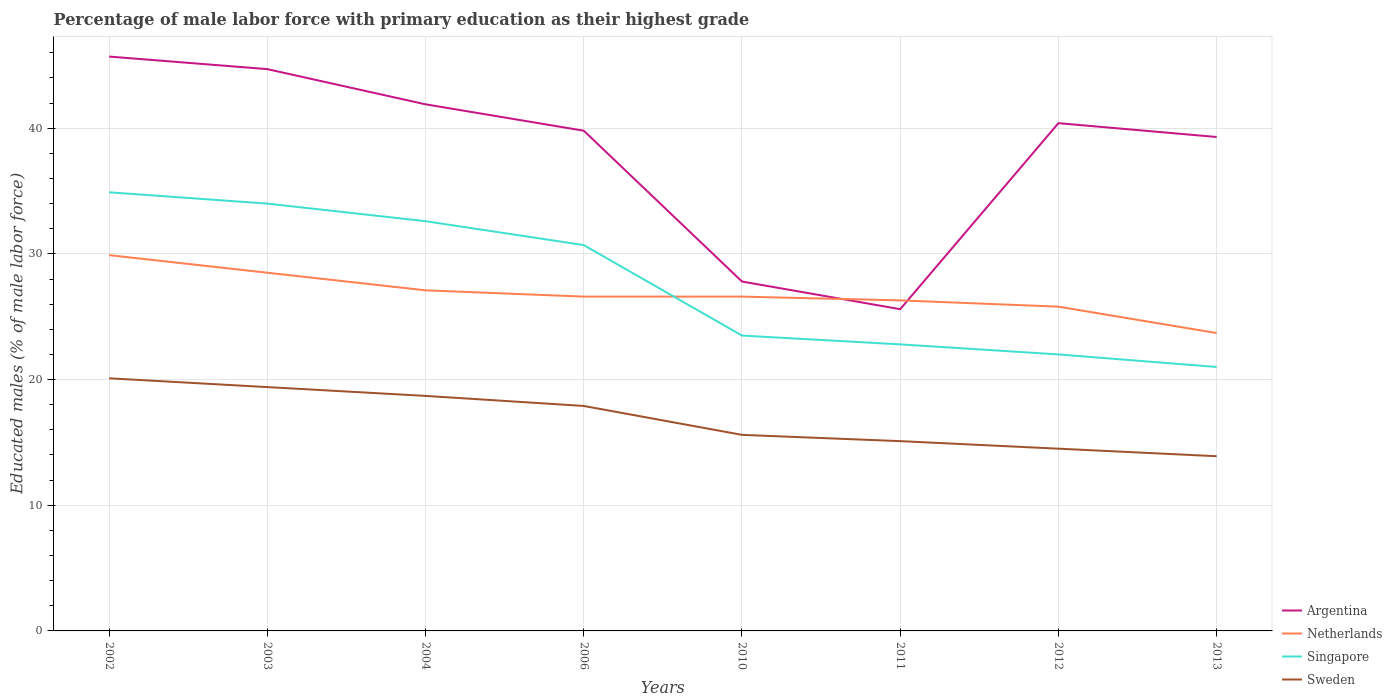How many different coloured lines are there?
Your answer should be compact. 4. Across all years, what is the maximum percentage of male labor force with primary education in Singapore?
Provide a short and direct response. 21. What is the total percentage of male labor force with primary education in Netherlands in the graph?
Make the answer very short. 2.6. What is the difference between the highest and the second highest percentage of male labor force with primary education in Argentina?
Offer a very short reply. 20.1. How many years are there in the graph?
Make the answer very short. 8. What is the difference between two consecutive major ticks on the Y-axis?
Make the answer very short. 10. Are the values on the major ticks of Y-axis written in scientific E-notation?
Offer a very short reply. No. Does the graph contain grids?
Your answer should be very brief. Yes. Where does the legend appear in the graph?
Your answer should be very brief. Bottom right. What is the title of the graph?
Offer a terse response. Percentage of male labor force with primary education as their highest grade. Does "Cayman Islands" appear as one of the legend labels in the graph?
Ensure brevity in your answer.  No. What is the label or title of the Y-axis?
Give a very brief answer. Educated males (% of male labor force). What is the Educated males (% of male labor force) of Argentina in 2002?
Offer a terse response. 45.7. What is the Educated males (% of male labor force) in Netherlands in 2002?
Your answer should be compact. 29.9. What is the Educated males (% of male labor force) in Singapore in 2002?
Ensure brevity in your answer.  34.9. What is the Educated males (% of male labor force) of Sweden in 2002?
Ensure brevity in your answer.  20.1. What is the Educated males (% of male labor force) in Argentina in 2003?
Your answer should be compact. 44.7. What is the Educated males (% of male labor force) in Singapore in 2003?
Offer a very short reply. 34. What is the Educated males (% of male labor force) of Sweden in 2003?
Your response must be concise. 19.4. What is the Educated males (% of male labor force) in Argentina in 2004?
Your response must be concise. 41.9. What is the Educated males (% of male labor force) of Netherlands in 2004?
Ensure brevity in your answer.  27.1. What is the Educated males (% of male labor force) in Singapore in 2004?
Keep it short and to the point. 32.6. What is the Educated males (% of male labor force) of Sweden in 2004?
Give a very brief answer. 18.7. What is the Educated males (% of male labor force) of Argentina in 2006?
Your answer should be compact. 39.8. What is the Educated males (% of male labor force) in Netherlands in 2006?
Make the answer very short. 26.6. What is the Educated males (% of male labor force) of Singapore in 2006?
Ensure brevity in your answer.  30.7. What is the Educated males (% of male labor force) of Sweden in 2006?
Your answer should be compact. 17.9. What is the Educated males (% of male labor force) in Argentina in 2010?
Offer a terse response. 27.8. What is the Educated males (% of male labor force) of Netherlands in 2010?
Offer a terse response. 26.6. What is the Educated males (% of male labor force) in Sweden in 2010?
Your answer should be compact. 15.6. What is the Educated males (% of male labor force) in Argentina in 2011?
Offer a terse response. 25.6. What is the Educated males (% of male labor force) of Netherlands in 2011?
Ensure brevity in your answer.  26.3. What is the Educated males (% of male labor force) in Singapore in 2011?
Keep it short and to the point. 22.8. What is the Educated males (% of male labor force) of Sweden in 2011?
Make the answer very short. 15.1. What is the Educated males (% of male labor force) of Argentina in 2012?
Provide a short and direct response. 40.4. What is the Educated males (% of male labor force) in Netherlands in 2012?
Your answer should be compact. 25.8. What is the Educated males (% of male labor force) of Singapore in 2012?
Offer a very short reply. 22. What is the Educated males (% of male labor force) of Argentina in 2013?
Provide a short and direct response. 39.3. What is the Educated males (% of male labor force) in Netherlands in 2013?
Provide a succinct answer. 23.7. What is the Educated males (% of male labor force) in Sweden in 2013?
Provide a succinct answer. 13.9. Across all years, what is the maximum Educated males (% of male labor force) of Argentina?
Make the answer very short. 45.7. Across all years, what is the maximum Educated males (% of male labor force) in Netherlands?
Provide a short and direct response. 29.9. Across all years, what is the maximum Educated males (% of male labor force) in Singapore?
Ensure brevity in your answer.  34.9. Across all years, what is the maximum Educated males (% of male labor force) in Sweden?
Your answer should be compact. 20.1. Across all years, what is the minimum Educated males (% of male labor force) of Argentina?
Your answer should be very brief. 25.6. Across all years, what is the minimum Educated males (% of male labor force) in Netherlands?
Offer a terse response. 23.7. Across all years, what is the minimum Educated males (% of male labor force) of Sweden?
Offer a very short reply. 13.9. What is the total Educated males (% of male labor force) of Argentina in the graph?
Ensure brevity in your answer.  305.2. What is the total Educated males (% of male labor force) of Netherlands in the graph?
Offer a terse response. 214.5. What is the total Educated males (% of male labor force) of Singapore in the graph?
Your response must be concise. 221.5. What is the total Educated males (% of male labor force) in Sweden in the graph?
Ensure brevity in your answer.  135.2. What is the difference between the Educated males (% of male labor force) of Argentina in 2002 and that in 2003?
Your answer should be very brief. 1. What is the difference between the Educated males (% of male labor force) of Singapore in 2002 and that in 2003?
Your answer should be very brief. 0.9. What is the difference between the Educated males (% of male labor force) of Sweden in 2002 and that in 2003?
Your answer should be very brief. 0.7. What is the difference between the Educated males (% of male labor force) of Argentina in 2002 and that in 2004?
Your answer should be very brief. 3.8. What is the difference between the Educated males (% of male labor force) of Singapore in 2002 and that in 2004?
Provide a short and direct response. 2.3. What is the difference between the Educated males (% of male labor force) of Sweden in 2002 and that in 2004?
Make the answer very short. 1.4. What is the difference between the Educated males (% of male labor force) in Sweden in 2002 and that in 2010?
Offer a terse response. 4.5. What is the difference between the Educated males (% of male labor force) of Argentina in 2002 and that in 2011?
Provide a succinct answer. 20.1. What is the difference between the Educated males (% of male labor force) of Netherlands in 2002 and that in 2011?
Your response must be concise. 3.6. What is the difference between the Educated males (% of male labor force) in Netherlands in 2002 and that in 2012?
Make the answer very short. 4.1. What is the difference between the Educated males (% of male labor force) in Singapore in 2002 and that in 2012?
Provide a succinct answer. 12.9. What is the difference between the Educated males (% of male labor force) of Sweden in 2002 and that in 2012?
Give a very brief answer. 5.6. What is the difference between the Educated males (% of male labor force) of Argentina in 2002 and that in 2013?
Your answer should be very brief. 6.4. What is the difference between the Educated males (% of male labor force) in Netherlands in 2002 and that in 2013?
Your answer should be compact. 6.2. What is the difference between the Educated males (% of male labor force) in Singapore in 2002 and that in 2013?
Provide a short and direct response. 13.9. What is the difference between the Educated males (% of male labor force) in Argentina in 2003 and that in 2004?
Provide a short and direct response. 2.8. What is the difference between the Educated males (% of male labor force) in Argentina in 2003 and that in 2006?
Your answer should be compact. 4.9. What is the difference between the Educated males (% of male labor force) of Netherlands in 2003 and that in 2006?
Keep it short and to the point. 1.9. What is the difference between the Educated males (% of male labor force) in Singapore in 2003 and that in 2006?
Your response must be concise. 3.3. What is the difference between the Educated males (% of male labor force) in Argentina in 2003 and that in 2010?
Your answer should be very brief. 16.9. What is the difference between the Educated males (% of male labor force) of Netherlands in 2003 and that in 2010?
Make the answer very short. 1.9. What is the difference between the Educated males (% of male labor force) in Singapore in 2003 and that in 2010?
Your response must be concise. 10.5. What is the difference between the Educated males (% of male labor force) in Netherlands in 2003 and that in 2011?
Offer a very short reply. 2.2. What is the difference between the Educated males (% of male labor force) of Singapore in 2003 and that in 2011?
Provide a short and direct response. 11.2. What is the difference between the Educated males (% of male labor force) in Argentina in 2003 and that in 2012?
Your answer should be compact. 4.3. What is the difference between the Educated males (% of male labor force) in Singapore in 2003 and that in 2012?
Offer a terse response. 12. What is the difference between the Educated males (% of male labor force) of Sweden in 2003 and that in 2012?
Your response must be concise. 4.9. What is the difference between the Educated males (% of male labor force) in Singapore in 2003 and that in 2013?
Your answer should be compact. 13. What is the difference between the Educated males (% of male labor force) in Argentina in 2004 and that in 2006?
Your answer should be compact. 2.1. What is the difference between the Educated males (% of male labor force) in Netherlands in 2004 and that in 2006?
Ensure brevity in your answer.  0.5. What is the difference between the Educated males (% of male labor force) of Sweden in 2004 and that in 2006?
Offer a very short reply. 0.8. What is the difference between the Educated males (% of male labor force) of Netherlands in 2004 and that in 2010?
Keep it short and to the point. 0.5. What is the difference between the Educated males (% of male labor force) of Singapore in 2004 and that in 2010?
Provide a succinct answer. 9.1. What is the difference between the Educated males (% of male labor force) of Sweden in 2004 and that in 2010?
Keep it short and to the point. 3.1. What is the difference between the Educated males (% of male labor force) in Argentina in 2004 and that in 2011?
Your response must be concise. 16.3. What is the difference between the Educated males (% of male labor force) in Netherlands in 2004 and that in 2011?
Offer a terse response. 0.8. What is the difference between the Educated males (% of male labor force) in Sweden in 2004 and that in 2011?
Make the answer very short. 3.6. What is the difference between the Educated males (% of male labor force) in Sweden in 2004 and that in 2013?
Your response must be concise. 4.8. What is the difference between the Educated males (% of male labor force) of Argentina in 2006 and that in 2010?
Give a very brief answer. 12. What is the difference between the Educated males (% of male labor force) in Netherlands in 2006 and that in 2010?
Your answer should be compact. 0. What is the difference between the Educated males (% of male labor force) of Singapore in 2006 and that in 2010?
Your response must be concise. 7.2. What is the difference between the Educated males (% of male labor force) of Sweden in 2006 and that in 2010?
Your answer should be compact. 2.3. What is the difference between the Educated males (% of male labor force) in Netherlands in 2006 and that in 2011?
Offer a terse response. 0.3. What is the difference between the Educated males (% of male labor force) in Argentina in 2006 and that in 2012?
Your answer should be compact. -0.6. What is the difference between the Educated males (% of male labor force) in Sweden in 2006 and that in 2012?
Offer a terse response. 3.4. What is the difference between the Educated males (% of male labor force) in Netherlands in 2006 and that in 2013?
Give a very brief answer. 2.9. What is the difference between the Educated males (% of male labor force) of Sweden in 2006 and that in 2013?
Offer a very short reply. 4. What is the difference between the Educated males (% of male labor force) in Singapore in 2010 and that in 2011?
Ensure brevity in your answer.  0.7. What is the difference between the Educated males (% of male labor force) of Argentina in 2010 and that in 2012?
Make the answer very short. -12.6. What is the difference between the Educated males (% of male labor force) of Netherlands in 2010 and that in 2012?
Make the answer very short. 0.8. What is the difference between the Educated males (% of male labor force) in Argentina in 2010 and that in 2013?
Provide a short and direct response. -11.5. What is the difference between the Educated males (% of male labor force) in Singapore in 2010 and that in 2013?
Make the answer very short. 2.5. What is the difference between the Educated males (% of male labor force) of Sweden in 2010 and that in 2013?
Provide a succinct answer. 1.7. What is the difference between the Educated males (% of male labor force) of Argentina in 2011 and that in 2012?
Give a very brief answer. -14.8. What is the difference between the Educated males (% of male labor force) in Netherlands in 2011 and that in 2012?
Make the answer very short. 0.5. What is the difference between the Educated males (% of male labor force) of Sweden in 2011 and that in 2012?
Offer a terse response. 0.6. What is the difference between the Educated males (% of male labor force) of Argentina in 2011 and that in 2013?
Your answer should be compact. -13.7. What is the difference between the Educated males (% of male labor force) in Singapore in 2011 and that in 2013?
Your answer should be compact. 1.8. What is the difference between the Educated males (% of male labor force) in Argentina in 2012 and that in 2013?
Ensure brevity in your answer.  1.1. What is the difference between the Educated males (% of male labor force) of Netherlands in 2012 and that in 2013?
Offer a very short reply. 2.1. What is the difference between the Educated males (% of male labor force) in Singapore in 2012 and that in 2013?
Give a very brief answer. 1. What is the difference between the Educated males (% of male labor force) of Argentina in 2002 and the Educated males (% of male labor force) of Netherlands in 2003?
Give a very brief answer. 17.2. What is the difference between the Educated males (% of male labor force) of Argentina in 2002 and the Educated males (% of male labor force) of Singapore in 2003?
Make the answer very short. 11.7. What is the difference between the Educated males (% of male labor force) of Argentina in 2002 and the Educated males (% of male labor force) of Sweden in 2003?
Make the answer very short. 26.3. What is the difference between the Educated males (% of male labor force) in Netherlands in 2002 and the Educated males (% of male labor force) in Singapore in 2003?
Make the answer very short. -4.1. What is the difference between the Educated males (% of male labor force) of Singapore in 2002 and the Educated males (% of male labor force) of Sweden in 2003?
Your response must be concise. 15.5. What is the difference between the Educated males (% of male labor force) in Argentina in 2002 and the Educated males (% of male labor force) in Sweden in 2004?
Your answer should be compact. 27. What is the difference between the Educated males (% of male labor force) in Argentina in 2002 and the Educated males (% of male labor force) in Netherlands in 2006?
Make the answer very short. 19.1. What is the difference between the Educated males (% of male labor force) in Argentina in 2002 and the Educated males (% of male labor force) in Singapore in 2006?
Make the answer very short. 15. What is the difference between the Educated males (% of male labor force) in Argentina in 2002 and the Educated males (% of male labor force) in Sweden in 2006?
Your response must be concise. 27.8. What is the difference between the Educated males (% of male labor force) of Singapore in 2002 and the Educated males (% of male labor force) of Sweden in 2006?
Provide a short and direct response. 17. What is the difference between the Educated males (% of male labor force) of Argentina in 2002 and the Educated males (% of male labor force) of Singapore in 2010?
Ensure brevity in your answer.  22.2. What is the difference between the Educated males (% of male labor force) of Argentina in 2002 and the Educated males (% of male labor force) of Sweden in 2010?
Offer a very short reply. 30.1. What is the difference between the Educated males (% of male labor force) in Netherlands in 2002 and the Educated males (% of male labor force) in Singapore in 2010?
Ensure brevity in your answer.  6.4. What is the difference between the Educated males (% of male labor force) of Netherlands in 2002 and the Educated males (% of male labor force) of Sweden in 2010?
Your answer should be very brief. 14.3. What is the difference between the Educated males (% of male labor force) in Singapore in 2002 and the Educated males (% of male labor force) in Sweden in 2010?
Your response must be concise. 19.3. What is the difference between the Educated males (% of male labor force) in Argentina in 2002 and the Educated males (% of male labor force) in Singapore in 2011?
Your answer should be very brief. 22.9. What is the difference between the Educated males (% of male labor force) in Argentina in 2002 and the Educated males (% of male labor force) in Sweden in 2011?
Keep it short and to the point. 30.6. What is the difference between the Educated males (% of male labor force) in Netherlands in 2002 and the Educated males (% of male labor force) in Sweden in 2011?
Your answer should be very brief. 14.8. What is the difference between the Educated males (% of male labor force) in Singapore in 2002 and the Educated males (% of male labor force) in Sweden in 2011?
Make the answer very short. 19.8. What is the difference between the Educated males (% of male labor force) of Argentina in 2002 and the Educated males (% of male labor force) of Netherlands in 2012?
Provide a short and direct response. 19.9. What is the difference between the Educated males (% of male labor force) in Argentina in 2002 and the Educated males (% of male labor force) in Singapore in 2012?
Your answer should be compact. 23.7. What is the difference between the Educated males (% of male labor force) of Argentina in 2002 and the Educated males (% of male labor force) of Sweden in 2012?
Offer a very short reply. 31.2. What is the difference between the Educated males (% of male labor force) in Netherlands in 2002 and the Educated males (% of male labor force) in Sweden in 2012?
Give a very brief answer. 15.4. What is the difference between the Educated males (% of male labor force) in Singapore in 2002 and the Educated males (% of male labor force) in Sweden in 2012?
Your answer should be very brief. 20.4. What is the difference between the Educated males (% of male labor force) in Argentina in 2002 and the Educated males (% of male labor force) in Singapore in 2013?
Keep it short and to the point. 24.7. What is the difference between the Educated males (% of male labor force) of Argentina in 2002 and the Educated males (% of male labor force) of Sweden in 2013?
Keep it short and to the point. 31.8. What is the difference between the Educated males (% of male labor force) of Netherlands in 2002 and the Educated males (% of male labor force) of Singapore in 2013?
Ensure brevity in your answer.  8.9. What is the difference between the Educated males (% of male labor force) in Netherlands in 2002 and the Educated males (% of male labor force) in Sweden in 2013?
Make the answer very short. 16. What is the difference between the Educated males (% of male labor force) of Singapore in 2002 and the Educated males (% of male labor force) of Sweden in 2013?
Offer a terse response. 21. What is the difference between the Educated males (% of male labor force) of Argentina in 2003 and the Educated males (% of male labor force) of Singapore in 2004?
Keep it short and to the point. 12.1. What is the difference between the Educated males (% of male labor force) in Netherlands in 2003 and the Educated males (% of male labor force) in Singapore in 2004?
Make the answer very short. -4.1. What is the difference between the Educated males (% of male labor force) of Netherlands in 2003 and the Educated males (% of male labor force) of Sweden in 2004?
Keep it short and to the point. 9.8. What is the difference between the Educated males (% of male labor force) in Singapore in 2003 and the Educated males (% of male labor force) in Sweden in 2004?
Your answer should be very brief. 15.3. What is the difference between the Educated males (% of male labor force) of Argentina in 2003 and the Educated males (% of male labor force) of Netherlands in 2006?
Make the answer very short. 18.1. What is the difference between the Educated males (% of male labor force) of Argentina in 2003 and the Educated males (% of male labor force) of Singapore in 2006?
Offer a very short reply. 14. What is the difference between the Educated males (% of male labor force) in Argentina in 2003 and the Educated males (% of male labor force) in Sweden in 2006?
Your response must be concise. 26.8. What is the difference between the Educated males (% of male labor force) of Netherlands in 2003 and the Educated males (% of male labor force) of Singapore in 2006?
Your answer should be compact. -2.2. What is the difference between the Educated males (% of male labor force) of Netherlands in 2003 and the Educated males (% of male labor force) of Sweden in 2006?
Keep it short and to the point. 10.6. What is the difference between the Educated males (% of male labor force) of Argentina in 2003 and the Educated males (% of male labor force) of Netherlands in 2010?
Provide a short and direct response. 18.1. What is the difference between the Educated males (% of male labor force) of Argentina in 2003 and the Educated males (% of male labor force) of Singapore in 2010?
Ensure brevity in your answer.  21.2. What is the difference between the Educated males (% of male labor force) of Argentina in 2003 and the Educated males (% of male labor force) of Sweden in 2010?
Offer a terse response. 29.1. What is the difference between the Educated males (% of male labor force) in Netherlands in 2003 and the Educated males (% of male labor force) in Singapore in 2010?
Provide a succinct answer. 5. What is the difference between the Educated males (% of male labor force) of Netherlands in 2003 and the Educated males (% of male labor force) of Sweden in 2010?
Offer a terse response. 12.9. What is the difference between the Educated males (% of male labor force) of Argentina in 2003 and the Educated males (% of male labor force) of Netherlands in 2011?
Make the answer very short. 18.4. What is the difference between the Educated males (% of male labor force) in Argentina in 2003 and the Educated males (% of male labor force) in Singapore in 2011?
Ensure brevity in your answer.  21.9. What is the difference between the Educated males (% of male labor force) in Argentina in 2003 and the Educated males (% of male labor force) in Sweden in 2011?
Provide a short and direct response. 29.6. What is the difference between the Educated males (% of male labor force) of Netherlands in 2003 and the Educated males (% of male labor force) of Singapore in 2011?
Provide a succinct answer. 5.7. What is the difference between the Educated males (% of male labor force) of Argentina in 2003 and the Educated males (% of male labor force) of Netherlands in 2012?
Offer a terse response. 18.9. What is the difference between the Educated males (% of male labor force) in Argentina in 2003 and the Educated males (% of male labor force) in Singapore in 2012?
Offer a very short reply. 22.7. What is the difference between the Educated males (% of male labor force) of Argentina in 2003 and the Educated males (% of male labor force) of Sweden in 2012?
Offer a terse response. 30.2. What is the difference between the Educated males (% of male labor force) in Netherlands in 2003 and the Educated males (% of male labor force) in Singapore in 2012?
Keep it short and to the point. 6.5. What is the difference between the Educated males (% of male labor force) of Argentina in 2003 and the Educated males (% of male labor force) of Netherlands in 2013?
Give a very brief answer. 21. What is the difference between the Educated males (% of male labor force) of Argentina in 2003 and the Educated males (% of male labor force) of Singapore in 2013?
Ensure brevity in your answer.  23.7. What is the difference between the Educated males (% of male labor force) in Argentina in 2003 and the Educated males (% of male labor force) in Sweden in 2013?
Your response must be concise. 30.8. What is the difference between the Educated males (% of male labor force) of Netherlands in 2003 and the Educated males (% of male labor force) of Singapore in 2013?
Give a very brief answer. 7.5. What is the difference between the Educated males (% of male labor force) in Singapore in 2003 and the Educated males (% of male labor force) in Sweden in 2013?
Give a very brief answer. 20.1. What is the difference between the Educated males (% of male labor force) in Netherlands in 2004 and the Educated males (% of male labor force) in Singapore in 2006?
Provide a succinct answer. -3.6. What is the difference between the Educated males (% of male labor force) in Singapore in 2004 and the Educated males (% of male labor force) in Sweden in 2006?
Offer a terse response. 14.7. What is the difference between the Educated males (% of male labor force) of Argentina in 2004 and the Educated males (% of male labor force) of Singapore in 2010?
Your answer should be compact. 18.4. What is the difference between the Educated males (% of male labor force) in Argentina in 2004 and the Educated males (% of male labor force) in Sweden in 2010?
Your answer should be compact. 26.3. What is the difference between the Educated males (% of male labor force) in Netherlands in 2004 and the Educated males (% of male labor force) in Singapore in 2010?
Ensure brevity in your answer.  3.6. What is the difference between the Educated males (% of male labor force) of Argentina in 2004 and the Educated males (% of male labor force) of Singapore in 2011?
Make the answer very short. 19.1. What is the difference between the Educated males (% of male labor force) of Argentina in 2004 and the Educated males (% of male labor force) of Sweden in 2011?
Provide a short and direct response. 26.8. What is the difference between the Educated males (% of male labor force) in Netherlands in 2004 and the Educated males (% of male labor force) in Sweden in 2011?
Ensure brevity in your answer.  12. What is the difference between the Educated males (% of male labor force) in Argentina in 2004 and the Educated males (% of male labor force) in Sweden in 2012?
Your answer should be very brief. 27.4. What is the difference between the Educated males (% of male labor force) of Netherlands in 2004 and the Educated males (% of male labor force) of Sweden in 2012?
Provide a short and direct response. 12.6. What is the difference between the Educated males (% of male labor force) in Argentina in 2004 and the Educated males (% of male labor force) in Singapore in 2013?
Keep it short and to the point. 20.9. What is the difference between the Educated males (% of male labor force) in Argentina in 2004 and the Educated males (% of male labor force) in Sweden in 2013?
Make the answer very short. 28. What is the difference between the Educated males (% of male labor force) in Netherlands in 2004 and the Educated males (% of male labor force) in Singapore in 2013?
Ensure brevity in your answer.  6.1. What is the difference between the Educated males (% of male labor force) in Netherlands in 2004 and the Educated males (% of male labor force) in Sweden in 2013?
Offer a terse response. 13.2. What is the difference between the Educated males (% of male labor force) of Argentina in 2006 and the Educated males (% of male labor force) of Netherlands in 2010?
Provide a short and direct response. 13.2. What is the difference between the Educated males (% of male labor force) of Argentina in 2006 and the Educated males (% of male labor force) of Sweden in 2010?
Make the answer very short. 24.2. What is the difference between the Educated males (% of male labor force) of Netherlands in 2006 and the Educated males (% of male labor force) of Sweden in 2010?
Keep it short and to the point. 11. What is the difference between the Educated males (% of male labor force) of Singapore in 2006 and the Educated males (% of male labor force) of Sweden in 2010?
Your response must be concise. 15.1. What is the difference between the Educated males (% of male labor force) of Argentina in 2006 and the Educated males (% of male labor force) of Netherlands in 2011?
Keep it short and to the point. 13.5. What is the difference between the Educated males (% of male labor force) of Argentina in 2006 and the Educated males (% of male labor force) of Sweden in 2011?
Offer a very short reply. 24.7. What is the difference between the Educated males (% of male labor force) in Netherlands in 2006 and the Educated males (% of male labor force) in Sweden in 2011?
Your answer should be compact. 11.5. What is the difference between the Educated males (% of male labor force) of Singapore in 2006 and the Educated males (% of male labor force) of Sweden in 2011?
Your answer should be very brief. 15.6. What is the difference between the Educated males (% of male labor force) of Argentina in 2006 and the Educated males (% of male labor force) of Netherlands in 2012?
Your answer should be very brief. 14. What is the difference between the Educated males (% of male labor force) of Argentina in 2006 and the Educated males (% of male labor force) of Sweden in 2012?
Your response must be concise. 25.3. What is the difference between the Educated males (% of male labor force) in Netherlands in 2006 and the Educated males (% of male labor force) in Singapore in 2012?
Keep it short and to the point. 4.6. What is the difference between the Educated males (% of male labor force) of Argentina in 2006 and the Educated males (% of male labor force) of Netherlands in 2013?
Ensure brevity in your answer.  16.1. What is the difference between the Educated males (% of male labor force) in Argentina in 2006 and the Educated males (% of male labor force) in Sweden in 2013?
Your answer should be compact. 25.9. What is the difference between the Educated males (% of male labor force) of Netherlands in 2006 and the Educated males (% of male labor force) of Singapore in 2013?
Offer a terse response. 5.6. What is the difference between the Educated males (% of male labor force) of Argentina in 2010 and the Educated males (% of male labor force) of Singapore in 2011?
Provide a short and direct response. 5. What is the difference between the Educated males (% of male labor force) of Argentina in 2010 and the Educated males (% of male labor force) of Sweden in 2011?
Provide a succinct answer. 12.7. What is the difference between the Educated males (% of male labor force) in Netherlands in 2010 and the Educated males (% of male labor force) in Singapore in 2011?
Your answer should be compact. 3.8. What is the difference between the Educated males (% of male labor force) in Netherlands in 2010 and the Educated males (% of male labor force) in Sweden in 2011?
Provide a succinct answer. 11.5. What is the difference between the Educated males (% of male labor force) in Argentina in 2010 and the Educated males (% of male labor force) in Netherlands in 2012?
Your response must be concise. 2. What is the difference between the Educated males (% of male labor force) in Argentina in 2010 and the Educated males (% of male labor force) in Singapore in 2012?
Make the answer very short. 5.8. What is the difference between the Educated males (% of male labor force) of Argentina in 2010 and the Educated males (% of male labor force) of Sweden in 2012?
Your answer should be very brief. 13.3. What is the difference between the Educated males (% of male labor force) in Netherlands in 2010 and the Educated males (% of male labor force) in Singapore in 2012?
Ensure brevity in your answer.  4.6. What is the difference between the Educated males (% of male labor force) of Netherlands in 2010 and the Educated males (% of male labor force) of Sweden in 2012?
Offer a terse response. 12.1. What is the difference between the Educated males (% of male labor force) in Argentina in 2010 and the Educated males (% of male labor force) in Netherlands in 2013?
Offer a very short reply. 4.1. What is the difference between the Educated males (% of male labor force) in Argentina in 2010 and the Educated males (% of male labor force) in Singapore in 2013?
Your answer should be compact. 6.8. What is the difference between the Educated males (% of male labor force) of Netherlands in 2010 and the Educated males (% of male labor force) of Singapore in 2013?
Ensure brevity in your answer.  5.6. What is the difference between the Educated males (% of male labor force) in Netherlands in 2010 and the Educated males (% of male labor force) in Sweden in 2013?
Offer a terse response. 12.7. What is the difference between the Educated males (% of male labor force) of Singapore in 2010 and the Educated males (% of male labor force) of Sweden in 2013?
Your answer should be compact. 9.6. What is the difference between the Educated males (% of male labor force) of Argentina in 2011 and the Educated males (% of male labor force) of Netherlands in 2013?
Give a very brief answer. 1.9. What is the difference between the Educated males (% of male labor force) in Argentina in 2011 and the Educated males (% of male labor force) in Singapore in 2013?
Give a very brief answer. 4.6. What is the difference between the Educated males (% of male labor force) in Argentina in 2011 and the Educated males (% of male labor force) in Sweden in 2013?
Provide a short and direct response. 11.7. What is the difference between the Educated males (% of male labor force) in Netherlands in 2011 and the Educated males (% of male labor force) in Sweden in 2013?
Provide a succinct answer. 12.4. What is the difference between the Educated males (% of male labor force) of Argentina in 2012 and the Educated males (% of male labor force) of Netherlands in 2013?
Ensure brevity in your answer.  16.7. What is the average Educated males (% of male labor force) of Argentina per year?
Offer a terse response. 38.15. What is the average Educated males (% of male labor force) of Netherlands per year?
Your response must be concise. 26.81. What is the average Educated males (% of male labor force) in Singapore per year?
Keep it short and to the point. 27.69. What is the average Educated males (% of male labor force) in Sweden per year?
Your answer should be compact. 16.9. In the year 2002, what is the difference between the Educated males (% of male labor force) in Argentina and Educated males (% of male labor force) in Singapore?
Make the answer very short. 10.8. In the year 2002, what is the difference between the Educated males (% of male labor force) in Argentina and Educated males (% of male labor force) in Sweden?
Provide a short and direct response. 25.6. In the year 2002, what is the difference between the Educated males (% of male labor force) in Netherlands and Educated males (% of male labor force) in Singapore?
Provide a short and direct response. -5. In the year 2003, what is the difference between the Educated males (% of male labor force) in Argentina and Educated males (% of male labor force) in Netherlands?
Make the answer very short. 16.2. In the year 2003, what is the difference between the Educated males (% of male labor force) in Argentina and Educated males (% of male labor force) in Sweden?
Keep it short and to the point. 25.3. In the year 2003, what is the difference between the Educated males (% of male labor force) of Netherlands and Educated males (% of male labor force) of Singapore?
Give a very brief answer. -5.5. In the year 2003, what is the difference between the Educated males (% of male labor force) of Netherlands and Educated males (% of male labor force) of Sweden?
Your answer should be very brief. 9.1. In the year 2003, what is the difference between the Educated males (% of male labor force) of Singapore and Educated males (% of male labor force) of Sweden?
Give a very brief answer. 14.6. In the year 2004, what is the difference between the Educated males (% of male labor force) in Argentina and Educated males (% of male labor force) in Netherlands?
Ensure brevity in your answer.  14.8. In the year 2004, what is the difference between the Educated males (% of male labor force) in Argentina and Educated males (% of male labor force) in Sweden?
Provide a succinct answer. 23.2. In the year 2004, what is the difference between the Educated males (% of male labor force) in Singapore and Educated males (% of male labor force) in Sweden?
Offer a terse response. 13.9. In the year 2006, what is the difference between the Educated males (% of male labor force) in Argentina and Educated males (% of male labor force) in Netherlands?
Offer a very short reply. 13.2. In the year 2006, what is the difference between the Educated males (% of male labor force) of Argentina and Educated males (% of male labor force) of Sweden?
Keep it short and to the point. 21.9. In the year 2006, what is the difference between the Educated males (% of male labor force) in Netherlands and Educated males (% of male labor force) in Singapore?
Offer a very short reply. -4.1. In the year 2006, what is the difference between the Educated males (% of male labor force) of Netherlands and Educated males (% of male labor force) of Sweden?
Give a very brief answer. 8.7. In the year 2006, what is the difference between the Educated males (% of male labor force) of Singapore and Educated males (% of male labor force) of Sweden?
Provide a succinct answer. 12.8. In the year 2010, what is the difference between the Educated males (% of male labor force) in Argentina and Educated males (% of male labor force) in Singapore?
Provide a succinct answer. 4.3. In the year 2010, what is the difference between the Educated males (% of male labor force) of Netherlands and Educated males (% of male labor force) of Sweden?
Your answer should be very brief. 11. In the year 2010, what is the difference between the Educated males (% of male labor force) of Singapore and Educated males (% of male labor force) of Sweden?
Provide a succinct answer. 7.9. In the year 2012, what is the difference between the Educated males (% of male labor force) in Argentina and Educated males (% of male labor force) in Netherlands?
Your answer should be compact. 14.6. In the year 2012, what is the difference between the Educated males (% of male labor force) of Argentina and Educated males (% of male labor force) of Sweden?
Your answer should be very brief. 25.9. In the year 2012, what is the difference between the Educated males (% of male labor force) in Singapore and Educated males (% of male labor force) in Sweden?
Give a very brief answer. 7.5. In the year 2013, what is the difference between the Educated males (% of male labor force) in Argentina and Educated males (% of male labor force) in Sweden?
Offer a terse response. 25.4. In the year 2013, what is the difference between the Educated males (% of male labor force) of Netherlands and Educated males (% of male labor force) of Singapore?
Offer a very short reply. 2.7. In the year 2013, what is the difference between the Educated males (% of male labor force) in Singapore and Educated males (% of male labor force) in Sweden?
Provide a succinct answer. 7.1. What is the ratio of the Educated males (% of male labor force) in Argentina in 2002 to that in 2003?
Keep it short and to the point. 1.02. What is the ratio of the Educated males (% of male labor force) of Netherlands in 2002 to that in 2003?
Make the answer very short. 1.05. What is the ratio of the Educated males (% of male labor force) in Singapore in 2002 to that in 2003?
Give a very brief answer. 1.03. What is the ratio of the Educated males (% of male labor force) in Sweden in 2002 to that in 2003?
Your answer should be very brief. 1.04. What is the ratio of the Educated males (% of male labor force) of Argentina in 2002 to that in 2004?
Keep it short and to the point. 1.09. What is the ratio of the Educated males (% of male labor force) of Netherlands in 2002 to that in 2004?
Keep it short and to the point. 1.1. What is the ratio of the Educated males (% of male labor force) of Singapore in 2002 to that in 2004?
Offer a very short reply. 1.07. What is the ratio of the Educated males (% of male labor force) of Sweden in 2002 to that in 2004?
Give a very brief answer. 1.07. What is the ratio of the Educated males (% of male labor force) of Argentina in 2002 to that in 2006?
Provide a succinct answer. 1.15. What is the ratio of the Educated males (% of male labor force) of Netherlands in 2002 to that in 2006?
Keep it short and to the point. 1.12. What is the ratio of the Educated males (% of male labor force) of Singapore in 2002 to that in 2006?
Offer a very short reply. 1.14. What is the ratio of the Educated males (% of male labor force) of Sweden in 2002 to that in 2006?
Give a very brief answer. 1.12. What is the ratio of the Educated males (% of male labor force) of Argentina in 2002 to that in 2010?
Your answer should be compact. 1.64. What is the ratio of the Educated males (% of male labor force) in Netherlands in 2002 to that in 2010?
Provide a succinct answer. 1.12. What is the ratio of the Educated males (% of male labor force) of Singapore in 2002 to that in 2010?
Your answer should be very brief. 1.49. What is the ratio of the Educated males (% of male labor force) in Sweden in 2002 to that in 2010?
Your answer should be compact. 1.29. What is the ratio of the Educated males (% of male labor force) of Argentina in 2002 to that in 2011?
Your answer should be very brief. 1.79. What is the ratio of the Educated males (% of male labor force) of Netherlands in 2002 to that in 2011?
Make the answer very short. 1.14. What is the ratio of the Educated males (% of male labor force) of Singapore in 2002 to that in 2011?
Provide a short and direct response. 1.53. What is the ratio of the Educated males (% of male labor force) of Sweden in 2002 to that in 2011?
Offer a very short reply. 1.33. What is the ratio of the Educated males (% of male labor force) of Argentina in 2002 to that in 2012?
Your answer should be compact. 1.13. What is the ratio of the Educated males (% of male labor force) in Netherlands in 2002 to that in 2012?
Provide a succinct answer. 1.16. What is the ratio of the Educated males (% of male labor force) of Singapore in 2002 to that in 2012?
Make the answer very short. 1.59. What is the ratio of the Educated males (% of male labor force) in Sweden in 2002 to that in 2012?
Offer a very short reply. 1.39. What is the ratio of the Educated males (% of male labor force) of Argentina in 2002 to that in 2013?
Your answer should be very brief. 1.16. What is the ratio of the Educated males (% of male labor force) in Netherlands in 2002 to that in 2013?
Give a very brief answer. 1.26. What is the ratio of the Educated males (% of male labor force) of Singapore in 2002 to that in 2013?
Offer a terse response. 1.66. What is the ratio of the Educated males (% of male labor force) of Sweden in 2002 to that in 2013?
Give a very brief answer. 1.45. What is the ratio of the Educated males (% of male labor force) of Argentina in 2003 to that in 2004?
Ensure brevity in your answer.  1.07. What is the ratio of the Educated males (% of male labor force) of Netherlands in 2003 to that in 2004?
Ensure brevity in your answer.  1.05. What is the ratio of the Educated males (% of male labor force) in Singapore in 2003 to that in 2004?
Your answer should be compact. 1.04. What is the ratio of the Educated males (% of male labor force) of Sweden in 2003 to that in 2004?
Your answer should be compact. 1.04. What is the ratio of the Educated males (% of male labor force) of Argentina in 2003 to that in 2006?
Offer a very short reply. 1.12. What is the ratio of the Educated males (% of male labor force) in Netherlands in 2003 to that in 2006?
Provide a short and direct response. 1.07. What is the ratio of the Educated males (% of male labor force) of Singapore in 2003 to that in 2006?
Provide a short and direct response. 1.11. What is the ratio of the Educated males (% of male labor force) of Sweden in 2003 to that in 2006?
Offer a very short reply. 1.08. What is the ratio of the Educated males (% of male labor force) of Argentina in 2003 to that in 2010?
Provide a succinct answer. 1.61. What is the ratio of the Educated males (% of male labor force) of Netherlands in 2003 to that in 2010?
Provide a succinct answer. 1.07. What is the ratio of the Educated males (% of male labor force) of Singapore in 2003 to that in 2010?
Give a very brief answer. 1.45. What is the ratio of the Educated males (% of male labor force) in Sweden in 2003 to that in 2010?
Your answer should be very brief. 1.24. What is the ratio of the Educated males (% of male labor force) in Argentina in 2003 to that in 2011?
Make the answer very short. 1.75. What is the ratio of the Educated males (% of male labor force) of Netherlands in 2003 to that in 2011?
Your response must be concise. 1.08. What is the ratio of the Educated males (% of male labor force) in Singapore in 2003 to that in 2011?
Keep it short and to the point. 1.49. What is the ratio of the Educated males (% of male labor force) in Sweden in 2003 to that in 2011?
Your answer should be very brief. 1.28. What is the ratio of the Educated males (% of male labor force) in Argentina in 2003 to that in 2012?
Your answer should be very brief. 1.11. What is the ratio of the Educated males (% of male labor force) in Netherlands in 2003 to that in 2012?
Your answer should be compact. 1.1. What is the ratio of the Educated males (% of male labor force) of Singapore in 2003 to that in 2012?
Your response must be concise. 1.55. What is the ratio of the Educated males (% of male labor force) of Sweden in 2003 to that in 2012?
Offer a very short reply. 1.34. What is the ratio of the Educated males (% of male labor force) in Argentina in 2003 to that in 2013?
Offer a terse response. 1.14. What is the ratio of the Educated males (% of male labor force) of Netherlands in 2003 to that in 2013?
Make the answer very short. 1.2. What is the ratio of the Educated males (% of male labor force) of Singapore in 2003 to that in 2013?
Give a very brief answer. 1.62. What is the ratio of the Educated males (% of male labor force) in Sweden in 2003 to that in 2013?
Ensure brevity in your answer.  1.4. What is the ratio of the Educated males (% of male labor force) in Argentina in 2004 to that in 2006?
Provide a short and direct response. 1.05. What is the ratio of the Educated males (% of male labor force) in Netherlands in 2004 to that in 2006?
Make the answer very short. 1.02. What is the ratio of the Educated males (% of male labor force) in Singapore in 2004 to that in 2006?
Your answer should be very brief. 1.06. What is the ratio of the Educated males (% of male labor force) in Sweden in 2004 to that in 2006?
Your response must be concise. 1.04. What is the ratio of the Educated males (% of male labor force) of Argentina in 2004 to that in 2010?
Provide a succinct answer. 1.51. What is the ratio of the Educated males (% of male labor force) in Netherlands in 2004 to that in 2010?
Offer a very short reply. 1.02. What is the ratio of the Educated males (% of male labor force) of Singapore in 2004 to that in 2010?
Provide a succinct answer. 1.39. What is the ratio of the Educated males (% of male labor force) in Sweden in 2004 to that in 2010?
Keep it short and to the point. 1.2. What is the ratio of the Educated males (% of male labor force) of Argentina in 2004 to that in 2011?
Provide a short and direct response. 1.64. What is the ratio of the Educated males (% of male labor force) in Netherlands in 2004 to that in 2011?
Your answer should be compact. 1.03. What is the ratio of the Educated males (% of male labor force) in Singapore in 2004 to that in 2011?
Your answer should be very brief. 1.43. What is the ratio of the Educated males (% of male labor force) of Sweden in 2004 to that in 2011?
Your answer should be very brief. 1.24. What is the ratio of the Educated males (% of male labor force) of Argentina in 2004 to that in 2012?
Keep it short and to the point. 1.04. What is the ratio of the Educated males (% of male labor force) in Netherlands in 2004 to that in 2012?
Offer a terse response. 1.05. What is the ratio of the Educated males (% of male labor force) of Singapore in 2004 to that in 2012?
Your answer should be very brief. 1.48. What is the ratio of the Educated males (% of male labor force) of Sweden in 2004 to that in 2012?
Ensure brevity in your answer.  1.29. What is the ratio of the Educated males (% of male labor force) in Argentina in 2004 to that in 2013?
Give a very brief answer. 1.07. What is the ratio of the Educated males (% of male labor force) of Netherlands in 2004 to that in 2013?
Keep it short and to the point. 1.14. What is the ratio of the Educated males (% of male labor force) in Singapore in 2004 to that in 2013?
Your response must be concise. 1.55. What is the ratio of the Educated males (% of male labor force) in Sweden in 2004 to that in 2013?
Offer a very short reply. 1.35. What is the ratio of the Educated males (% of male labor force) of Argentina in 2006 to that in 2010?
Offer a terse response. 1.43. What is the ratio of the Educated males (% of male labor force) of Netherlands in 2006 to that in 2010?
Your answer should be compact. 1. What is the ratio of the Educated males (% of male labor force) in Singapore in 2006 to that in 2010?
Give a very brief answer. 1.31. What is the ratio of the Educated males (% of male labor force) in Sweden in 2006 to that in 2010?
Keep it short and to the point. 1.15. What is the ratio of the Educated males (% of male labor force) of Argentina in 2006 to that in 2011?
Your answer should be very brief. 1.55. What is the ratio of the Educated males (% of male labor force) of Netherlands in 2006 to that in 2011?
Provide a succinct answer. 1.01. What is the ratio of the Educated males (% of male labor force) of Singapore in 2006 to that in 2011?
Give a very brief answer. 1.35. What is the ratio of the Educated males (% of male labor force) in Sweden in 2006 to that in 2011?
Give a very brief answer. 1.19. What is the ratio of the Educated males (% of male labor force) of Argentina in 2006 to that in 2012?
Keep it short and to the point. 0.99. What is the ratio of the Educated males (% of male labor force) in Netherlands in 2006 to that in 2012?
Ensure brevity in your answer.  1.03. What is the ratio of the Educated males (% of male labor force) in Singapore in 2006 to that in 2012?
Your response must be concise. 1.4. What is the ratio of the Educated males (% of male labor force) of Sweden in 2006 to that in 2012?
Your answer should be compact. 1.23. What is the ratio of the Educated males (% of male labor force) in Argentina in 2006 to that in 2013?
Your response must be concise. 1.01. What is the ratio of the Educated males (% of male labor force) in Netherlands in 2006 to that in 2013?
Your answer should be compact. 1.12. What is the ratio of the Educated males (% of male labor force) in Singapore in 2006 to that in 2013?
Provide a succinct answer. 1.46. What is the ratio of the Educated males (% of male labor force) in Sweden in 2006 to that in 2013?
Your answer should be compact. 1.29. What is the ratio of the Educated males (% of male labor force) in Argentina in 2010 to that in 2011?
Make the answer very short. 1.09. What is the ratio of the Educated males (% of male labor force) in Netherlands in 2010 to that in 2011?
Give a very brief answer. 1.01. What is the ratio of the Educated males (% of male labor force) in Singapore in 2010 to that in 2011?
Provide a succinct answer. 1.03. What is the ratio of the Educated males (% of male labor force) in Sweden in 2010 to that in 2011?
Your answer should be very brief. 1.03. What is the ratio of the Educated males (% of male labor force) of Argentina in 2010 to that in 2012?
Your response must be concise. 0.69. What is the ratio of the Educated males (% of male labor force) of Netherlands in 2010 to that in 2012?
Provide a short and direct response. 1.03. What is the ratio of the Educated males (% of male labor force) in Singapore in 2010 to that in 2012?
Offer a very short reply. 1.07. What is the ratio of the Educated males (% of male labor force) of Sweden in 2010 to that in 2012?
Your response must be concise. 1.08. What is the ratio of the Educated males (% of male labor force) of Argentina in 2010 to that in 2013?
Offer a terse response. 0.71. What is the ratio of the Educated males (% of male labor force) of Netherlands in 2010 to that in 2013?
Ensure brevity in your answer.  1.12. What is the ratio of the Educated males (% of male labor force) of Singapore in 2010 to that in 2013?
Provide a succinct answer. 1.12. What is the ratio of the Educated males (% of male labor force) in Sweden in 2010 to that in 2013?
Your answer should be very brief. 1.12. What is the ratio of the Educated males (% of male labor force) of Argentina in 2011 to that in 2012?
Provide a succinct answer. 0.63. What is the ratio of the Educated males (% of male labor force) of Netherlands in 2011 to that in 2012?
Your response must be concise. 1.02. What is the ratio of the Educated males (% of male labor force) in Singapore in 2011 to that in 2012?
Your answer should be compact. 1.04. What is the ratio of the Educated males (% of male labor force) of Sweden in 2011 to that in 2012?
Your answer should be very brief. 1.04. What is the ratio of the Educated males (% of male labor force) of Argentina in 2011 to that in 2013?
Give a very brief answer. 0.65. What is the ratio of the Educated males (% of male labor force) of Netherlands in 2011 to that in 2013?
Offer a very short reply. 1.11. What is the ratio of the Educated males (% of male labor force) in Singapore in 2011 to that in 2013?
Your response must be concise. 1.09. What is the ratio of the Educated males (% of male labor force) in Sweden in 2011 to that in 2013?
Keep it short and to the point. 1.09. What is the ratio of the Educated males (% of male labor force) of Argentina in 2012 to that in 2013?
Your answer should be compact. 1.03. What is the ratio of the Educated males (% of male labor force) of Netherlands in 2012 to that in 2013?
Your answer should be compact. 1.09. What is the ratio of the Educated males (% of male labor force) in Singapore in 2012 to that in 2013?
Your response must be concise. 1.05. What is the ratio of the Educated males (% of male labor force) in Sweden in 2012 to that in 2013?
Offer a very short reply. 1.04. What is the difference between the highest and the second highest Educated males (% of male labor force) of Argentina?
Your response must be concise. 1. What is the difference between the highest and the second highest Educated males (% of male labor force) in Singapore?
Provide a succinct answer. 0.9. What is the difference between the highest and the second highest Educated males (% of male labor force) of Sweden?
Your answer should be compact. 0.7. What is the difference between the highest and the lowest Educated males (% of male labor force) of Argentina?
Keep it short and to the point. 20.1. What is the difference between the highest and the lowest Educated males (% of male labor force) of Singapore?
Your answer should be compact. 13.9. What is the difference between the highest and the lowest Educated males (% of male labor force) of Sweden?
Your answer should be very brief. 6.2. 